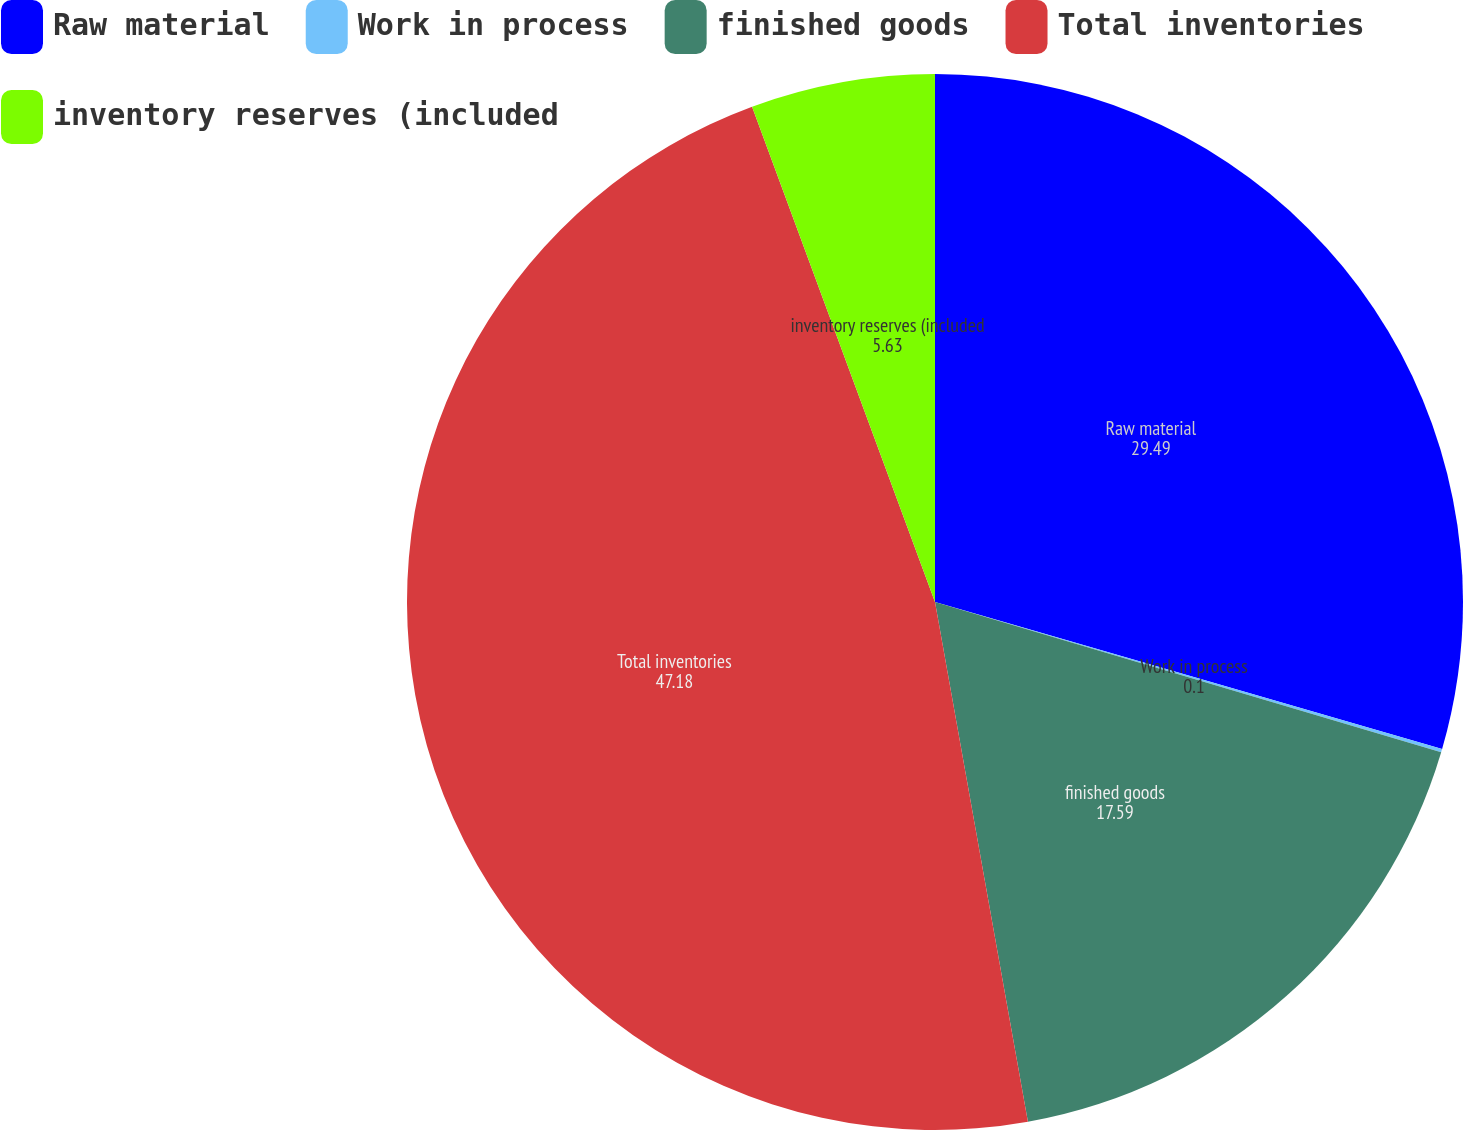<chart> <loc_0><loc_0><loc_500><loc_500><pie_chart><fcel>Raw material<fcel>Work in process<fcel>finished goods<fcel>Total inventories<fcel>inventory reserves (included<nl><fcel>29.49%<fcel>0.1%<fcel>17.59%<fcel>47.18%<fcel>5.63%<nl></chart> 